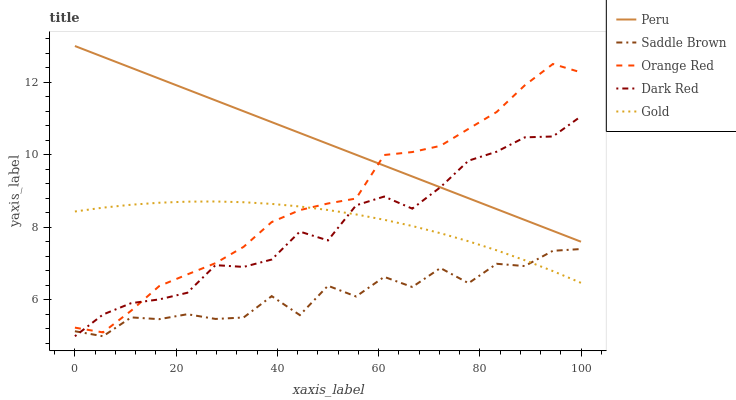Does Saddle Brown have the minimum area under the curve?
Answer yes or no. Yes. Does Peru have the maximum area under the curve?
Answer yes or no. Yes. Does Gold have the minimum area under the curve?
Answer yes or no. No. Does Gold have the maximum area under the curve?
Answer yes or no. No. Is Peru the smoothest?
Answer yes or no. Yes. Is Saddle Brown the roughest?
Answer yes or no. Yes. Is Gold the smoothest?
Answer yes or no. No. Is Gold the roughest?
Answer yes or no. No. Does Dark Red have the lowest value?
Answer yes or no. Yes. Does Gold have the lowest value?
Answer yes or no. No. Does Peru have the highest value?
Answer yes or no. Yes. Does Gold have the highest value?
Answer yes or no. No. Is Gold less than Peru?
Answer yes or no. Yes. Is Peru greater than Saddle Brown?
Answer yes or no. Yes. Does Orange Red intersect Dark Red?
Answer yes or no. Yes. Is Orange Red less than Dark Red?
Answer yes or no. No. Is Orange Red greater than Dark Red?
Answer yes or no. No. Does Gold intersect Peru?
Answer yes or no. No. 